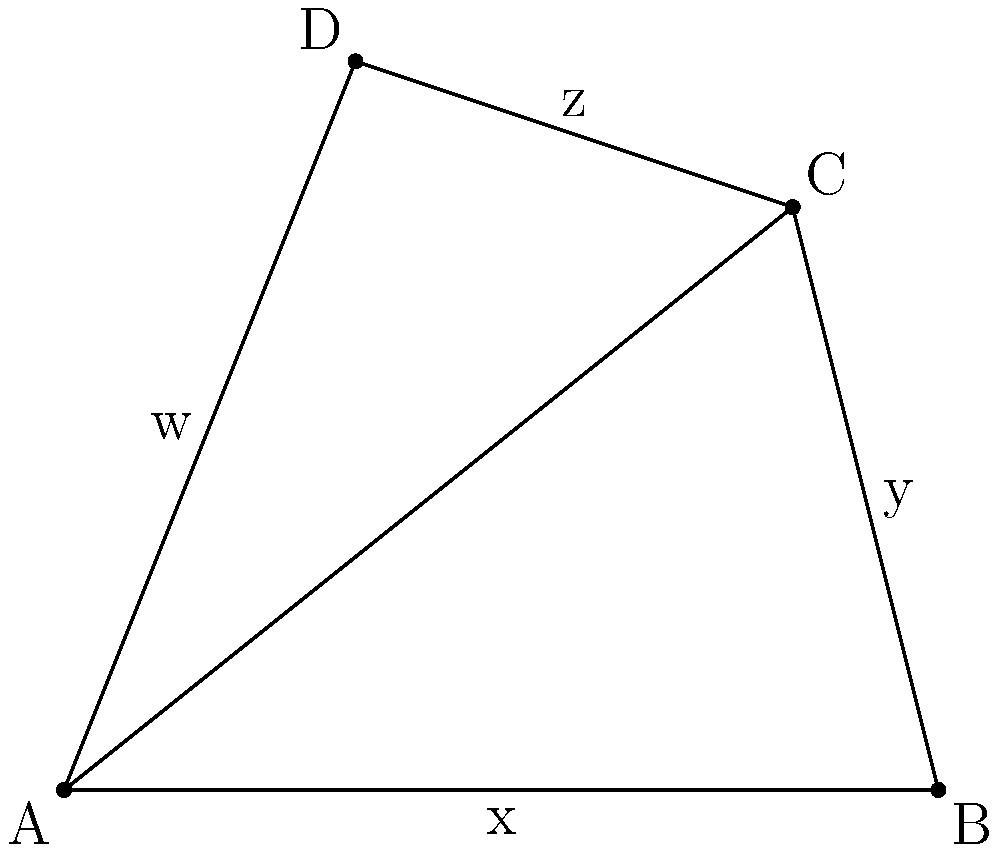In a novel, four characters are represented by points on a coordinate plane: A(0,0), B(6,0), C(5,4), and D(2,5). The relationships between these characters form a quadrilateral ABCD. Calculate the area of this quadrilateral to determine the complexity of their interconnected storylines. To find the area of the quadrilateral ABCD, we can use the following steps:

1) Divide the quadrilateral into two triangles by drawing the diagonal AC.

2) Calculate the area of triangle ABC:
   Area of ABC = $\frac{1}{2}$ * base * height
   Base (AB) = 6
   Height (perpendicular from C to AB) = 4
   Area of ABC = $\frac{1}{2}$ * 6 * 4 = 12

3) Calculate the area of triangle ACD:
   We can use the formula: Area = $\frac{1}{2}|x_1(y_2 - y_3) + x_2(y_3 - y_1) + x_3(y_1 - y_2)|$
   Where $(x_1,y_1)$, $(x_2,y_2)$, and $(x_3,y_3)$ are the coordinates of the three points.
   
   Area of ACD = $\frac{1}{2}|0(4 - 5) + 5(5 - 0) + 2(0 - 4)|$
                = $\frac{1}{2}|0 + 25 - 8|$
                = $\frac{1}{2} * 17$
                = 8.5

4) The total area of quadrilateral ABCD is the sum of these two triangles:
   Total Area = Area of ABC + Area of ACD
               = 12 + 8.5
               = 20.5

Therefore, the area of the quadrilateral ABCD is 20.5 square units.
Answer: 20.5 square units 